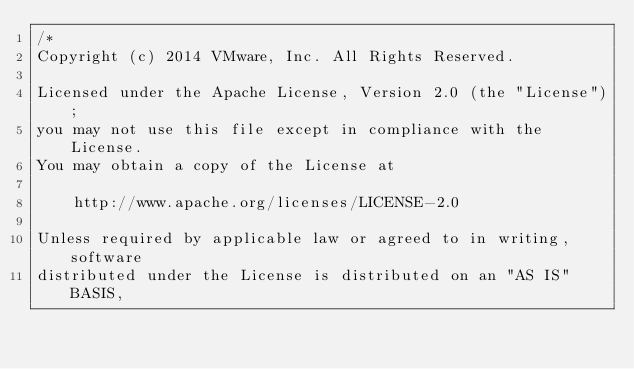<code> <loc_0><loc_0><loc_500><loc_500><_Go_>/*
Copyright (c) 2014 VMware, Inc. All Rights Reserved.

Licensed under the Apache License, Version 2.0 (the "License");
you may not use this file except in compliance with the License.
You may obtain a copy of the License at

    http://www.apache.org/licenses/LICENSE-2.0

Unless required by applicable law or agreed to in writing, software
distributed under the License is distributed on an "AS IS" BASIS,</code> 